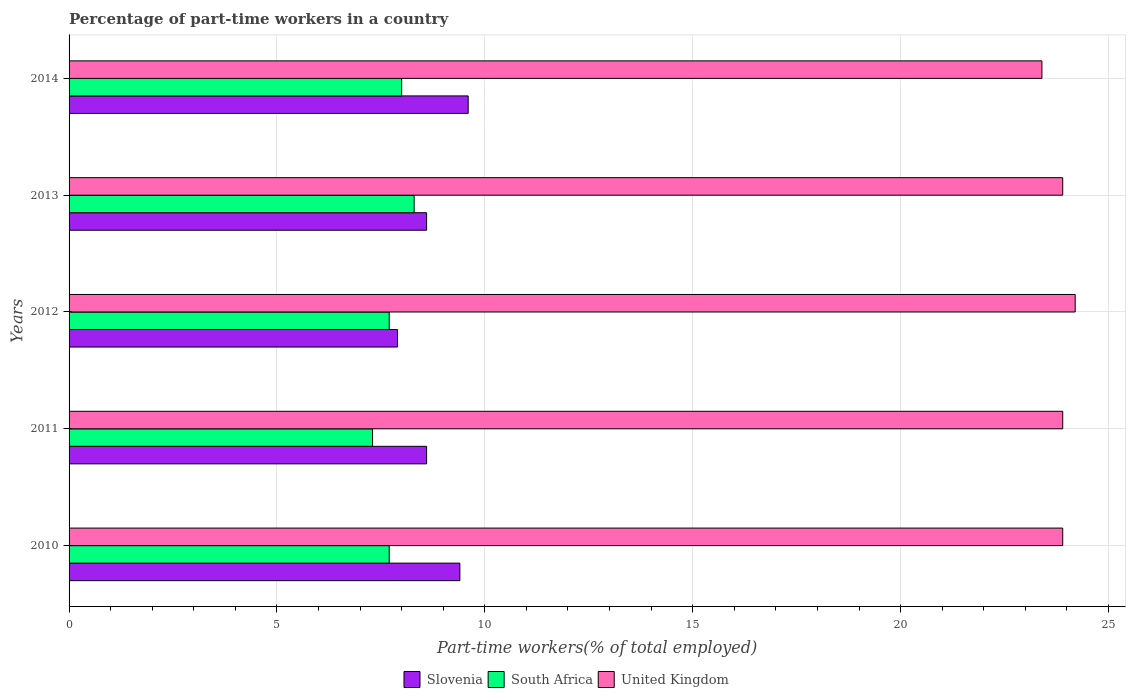How many different coloured bars are there?
Make the answer very short. 3. Are the number of bars per tick equal to the number of legend labels?
Ensure brevity in your answer.  Yes. Are the number of bars on each tick of the Y-axis equal?
Provide a succinct answer. Yes. What is the label of the 3rd group of bars from the top?
Make the answer very short. 2012. In how many cases, is the number of bars for a given year not equal to the number of legend labels?
Your response must be concise. 0. What is the percentage of part-time workers in South Africa in 2012?
Your answer should be very brief. 7.7. Across all years, what is the maximum percentage of part-time workers in Slovenia?
Keep it short and to the point. 9.6. Across all years, what is the minimum percentage of part-time workers in United Kingdom?
Make the answer very short. 23.4. In which year was the percentage of part-time workers in Slovenia maximum?
Make the answer very short. 2014. In which year was the percentage of part-time workers in Slovenia minimum?
Keep it short and to the point. 2012. What is the total percentage of part-time workers in United Kingdom in the graph?
Offer a terse response. 119.3. What is the difference between the percentage of part-time workers in South Africa in 2012 and that in 2013?
Offer a terse response. -0.6. What is the difference between the percentage of part-time workers in United Kingdom in 2010 and the percentage of part-time workers in South Africa in 2014?
Ensure brevity in your answer.  15.9. What is the average percentage of part-time workers in South Africa per year?
Keep it short and to the point. 7.8. In the year 2010, what is the difference between the percentage of part-time workers in United Kingdom and percentage of part-time workers in South Africa?
Ensure brevity in your answer.  16.2. What is the ratio of the percentage of part-time workers in Slovenia in 2011 to that in 2014?
Your answer should be very brief. 0.9. Is the difference between the percentage of part-time workers in United Kingdom in 2012 and 2013 greater than the difference between the percentage of part-time workers in South Africa in 2012 and 2013?
Ensure brevity in your answer.  Yes. What is the difference between the highest and the second highest percentage of part-time workers in Slovenia?
Ensure brevity in your answer.  0.2. What is the difference between the highest and the lowest percentage of part-time workers in Slovenia?
Make the answer very short. 1.7. In how many years, is the percentage of part-time workers in Slovenia greater than the average percentage of part-time workers in Slovenia taken over all years?
Your answer should be compact. 2. What does the 1st bar from the bottom in 2011 represents?
Make the answer very short. Slovenia. Is it the case that in every year, the sum of the percentage of part-time workers in Slovenia and percentage of part-time workers in South Africa is greater than the percentage of part-time workers in United Kingdom?
Provide a short and direct response. No. Are all the bars in the graph horizontal?
Provide a succinct answer. Yes. What is the difference between two consecutive major ticks on the X-axis?
Make the answer very short. 5. Does the graph contain any zero values?
Your answer should be compact. No. Does the graph contain grids?
Your answer should be compact. Yes. Where does the legend appear in the graph?
Your answer should be very brief. Bottom center. How many legend labels are there?
Keep it short and to the point. 3. What is the title of the graph?
Give a very brief answer. Percentage of part-time workers in a country. What is the label or title of the X-axis?
Provide a short and direct response. Part-time workers(% of total employed). What is the Part-time workers(% of total employed) of Slovenia in 2010?
Your answer should be very brief. 9.4. What is the Part-time workers(% of total employed) in South Africa in 2010?
Offer a very short reply. 7.7. What is the Part-time workers(% of total employed) of United Kingdom in 2010?
Keep it short and to the point. 23.9. What is the Part-time workers(% of total employed) of Slovenia in 2011?
Your answer should be very brief. 8.6. What is the Part-time workers(% of total employed) of South Africa in 2011?
Offer a very short reply. 7.3. What is the Part-time workers(% of total employed) in United Kingdom in 2011?
Keep it short and to the point. 23.9. What is the Part-time workers(% of total employed) of Slovenia in 2012?
Your response must be concise. 7.9. What is the Part-time workers(% of total employed) in South Africa in 2012?
Keep it short and to the point. 7.7. What is the Part-time workers(% of total employed) in United Kingdom in 2012?
Offer a very short reply. 24.2. What is the Part-time workers(% of total employed) of Slovenia in 2013?
Offer a terse response. 8.6. What is the Part-time workers(% of total employed) of South Africa in 2013?
Give a very brief answer. 8.3. What is the Part-time workers(% of total employed) of United Kingdom in 2013?
Give a very brief answer. 23.9. What is the Part-time workers(% of total employed) in Slovenia in 2014?
Your response must be concise. 9.6. What is the Part-time workers(% of total employed) of South Africa in 2014?
Ensure brevity in your answer.  8. What is the Part-time workers(% of total employed) of United Kingdom in 2014?
Make the answer very short. 23.4. Across all years, what is the maximum Part-time workers(% of total employed) in Slovenia?
Give a very brief answer. 9.6. Across all years, what is the maximum Part-time workers(% of total employed) of South Africa?
Ensure brevity in your answer.  8.3. Across all years, what is the maximum Part-time workers(% of total employed) in United Kingdom?
Your answer should be very brief. 24.2. Across all years, what is the minimum Part-time workers(% of total employed) in Slovenia?
Provide a short and direct response. 7.9. Across all years, what is the minimum Part-time workers(% of total employed) in South Africa?
Offer a terse response. 7.3. Across all years, what is the minimum Part-time workers(% of total employed) of United Kingdom?
Your response must be concise. 23.4. What is the total Part-time workers(% of total employed) in Slovenia in the graph?
Your answer should be very brief. 44.1. What is the total Part-time workers(% of total employed) in United Kingdom in the graph?
Give a very brief answer. 119.3. What is the difference between the Part-time workers(% of total employed) in Slovenia in 2010 and that in 2011?
Your answer should be compact. 0.8. What is the difference between the Part-time workers(% of total employed) of South Africa in 2010 and that in 2011?
Keep it short and to the point. 0.4. What is the difference between the Part-time workers(% of total employed) of Slovenia in 2010 and that in 2012?
Your response must be concise. 1.5. What is the difference between the Part-time workers(% of total employed) in South Africa in 2010 and that in 2012?
Provide a short and direct response. 0. What is the difference between the Part-time workers(% of total employed) in United Kingdom in 2010 and that in 2012?
Provide a short and direct response. -0.3. What is the difference between the Part-time workers(% of total employed) of South Africa in 2010 and that in 2013?
Keep it short and to the point. -0.6. What is the difference between the Part-time workers(% of total employed) in United Kingdom in 2010 and that in 2013?
Provide a short and direct response. 0. What is the difference between the Part-time workers(% of total employed) in Slovenia in 2010 and that in 2014?
Keep it short and to the point. -0.2. What is the difference between the Part-time workers(% of total employed) in South Africa in 2010 and that in 2014?
Give a very brief answer. -0.3. What is the difference between the Part-time workers(% of total employed) of United Kingdom in 2011 and that in 2012?
Provide a short and direct response. -0.3. What is the difference between the Part-time workers(% of total employed) of South Africa in 2012 and that in 2013?
Your response must be concise. -0.6. What is the difference between the Part-time workers(% of total employed) in Slovenia in 2012 and that in 2014?
Your response must be concise. -1.7. What is the difference between the Part-time workers(% of total employed) in United Kingdom in 2012 and that in 2014?
Ensure brevity in your answer.  0.8. What is the difference between the Part-time workers(% of total employed) in Slovenia in 2013 and that in 2014?
Provide a short and direct response. -1. What is the difference between the Part-time workers(% of total employed) in United Kingdom in 2013 and that in 2014?
Keep it short and to the point. 0.5. What is the difference between the Part-time workers(% of total employed) of Slovenia in 2010 and the Part-time workers(% of total employed) of South Africa in 2011?
Your response must be concise. 2.1. What is the difference between the Part-time workers(% of total employed) in Slovenia in 2010 and the Part-time workers(% of total employed) in United Kingdom in 2011?
Offer a very short reply. -14.5. What is the difference between the Part-time workers(% of total employed) of South Africa in 2010 and the Part-time workers(% of total employed) of United Kingdom in 2011?
Make the answer very short. -16.2. What is the difference between the Part-time workers(% of total employed) in Slovenia in 2010 and the Part-time workers(% of total employed) in United Kingdom in 2012?
Offer a very short reply. -14.8. What is the difference between the Part-time workers(% of total employed) of South Africa in 2010 and the Part-time workers(% of total employed) of United Kingdom in 2012?
Make the answer very short. -16.5. What is the difference between the Part-time workers(% of total employed) of Slovenia in 2010 and the Part-time workers(% of total employed) of United Kingdom in 2013?
Your response must be concise. -14.5. What is the difference between the Part-time workers(% of total employed) of South Africa in 2010 and the Part-time workers(% of total employed) of United Kingdom in 2013?
Your answer should be compact. -16.2. What is the difference between the Part-time workers(% of total employed) of Slovenia in 2010 and the Part-time workers(% of total employed) of South Africa in 2014?
Your answer should be compact. 1.4. What is the difference between the Part-time workers(% of total employed) in South Africa in 2010 and the Part-time workers(% of total employed) in United Kingdom in 2014?
Your response must be concise. -15.7. What is the difference between the Part-time workers(% of total employed) in Slovenia in 2011 and the Part-time workers(% of total employed) in South Africa in 2012?
Your response must be concise. 0.9. What is the difference between the Part-time workers(% of total employed) in Slovenia in 2011 and the Part-time workers(% of total employed) in United Kingdom in 2012?
Your answer should be compact. -15.6. What is the difference between the Part-time workers(% of total employed) of South Africa in 2011 and the Part-time workers(% of total employed) of United Kingdom in 2012?
Keep it short and to the point. -16.9. What is the difference between the Part-time workers(% of total employed) in Slovenia in 2011 and the Part-time workers(% of total employed) in South Africa in 2013?
Provide a short and direct response. 0.3. What is the difference between the Part-time workers(% of total employed) in Slovenia in 2011 and the Part-time workers(% of total employed) in United Kingdom in 2013?
Your response must be concise. -15.3. What is the difference between the Part-time workers(% of total employed) in South Africa in 2011 and the Part-time workers(% of total employed) in United Kingdom in 2013?
Your response must be concise. -16.6. What is the difference between the Part-time workers(% of total employed) of Slovenia in 2011 and the Part-time workers(% of total employed) of South Africa in 2014?
Your response must be concise. 0.6. What is the difference between the Part-time workers(% of total employed) of Slovenia in 2011 and the Part-time workers(% of total employed) of United Kingdom in 2014?
Make the answer very short. -14.8. What is the difference between the Part-time workers(% of total employed) in South Africa in 2011 and the Part-time workers(% of total employed) in United Kingdom in 2014?
Your answer should be compact. -16.1. What is the difference between the Part-time workers(% of total employed) in Slovenia in 2012 and the Part-time workers(% of total employed) in South Africa in 2013?
Provide a succinct answer. -0.4. What is the difference between the Part-time workers(% of total employed) in Slovenia in 2012 and the Part-time workers(% of total employed) in United Kingdom in 2013?
Provide a short and direct response. -16. What is the difference between the Part-time workers(% of total employed) of South Africa in 2012 and the Part-time workers(% of total employed) of United Kingdom in 2013?
Your answer should be very brief. -16.2. What is the difference between the Part-time workers(% of total employed) in Slovenia in 2012 and the Part-time workers(% of total employed) in United Kingdom in 2014?
Give a very brief answer. -15.5. What is the difference between the Part-time workers(% of total employed) in South Africa in 2012 and the Part-time workers(% of total employed) in United Kingdom in 2014?
Your response must be concise. -15.7. What is the difference between the Part-time workers(% of total employed) of Slovenia in 2013 and the Part-time workers(% of total employed) of United Kingdom in 2014?
Your answer should be compact. -14.8. What is the difference between the Part-time workers(% of total employed) of South Africa in 2013 and the Part-time workers(% of total employed) of United Kingdom in 2014?
Your answer should be compact. -15.1. What is the average Part-time workers(% of total employed) of Slovenia per year?
Offer a terse response. 8.82. What is the average Part-time workers(% of total employed) in South Africa per year?
Provide a succinct answer. 7.8. What is the average Part-time workers(% of total employed) in United Kingdom per year?
Keep it short and to the point. 23.86. In the year 2010, what is the difference between the Part-time workers(% of total employed) in South Africa and Part-time workers(% of total employed) in United Kingdom?
Offer a terse response. -16.2. In the year 2011, what is the difference between the Part-time workers(% of total employed) of Slovenia and Part-time workers(% of total employed) of South Africa?
Keep it short and to the point. 1.3. In the year 2011, what is the difference between the Part-time workers(% of total employed) of Slovenia and Part-time workers(% of total employed) of United Kingdom?
Offer a very short reply. -15.3. In the year 2011, what is the difference between the Part-time workers(% of total employed) in South Africa and Part-time workers(% of total employed) in United Kingdom?
Your answer should be compact. -16.6. In the year 2012, what is the difference between the Part-time workers(% of total employed) of Slovenia and Part-time workers(% of total employed) of South Africa?
Your response must be concise. 0.2. In the year 2012, what is the difference between the Part-time workers(% of total employed) of Slovenia and Part-time workers(% of total employed) of United Kingdom?
Your answer should be compact. -16.3. In the year 2012, what is the difference between the Part-time workers(% of total employed) of South Africa and Part-time workers(% of total employed) of United Kingdom?
Offer a very short reply. -16.5. In the year 2013, what is the difference between the Part-time workers(% of total employed) in Slovenia and Part-time workers(% of total employed) in United Kingdom?
Ensure brevity in your answer.  -15.3. In the year 2013, what is the difference between the Part-time workers(% of total employed) of South Africa and Part-time workers(% of total employed) of United Kingdom?
Offer a very short reply. -15.6. In the year 2014, what is the difference between the Part-time workers(% of total employed) in Slovenia and Part-time workers(% of total employed) in United Kingdom?
Ensure brevity in your answer.  -13.8. In the year 2014, what is the difference between the Part-time workers(% of total employed) in South Africa and Part-time workers(% of total employed) in United Kingdom?
Your answer should be compact. -15.4. What is the ratio of the Part-time workers(% of total employed) of Slovenia in 2010 to that in 2011?
Provide a short and direct response. 1.09. What is the ratio of the Part-time workers(% of total employed) in South Africa in 2010 to that in 2011?
Provide a short and direct response. 1.05. What is the ratio of the Part-time workers(% of total employed) of United Kingdom in 2010 to that in 2011?
Provide a succinct answer. 1. What is the ratio of the Part-time workers(% of total employed) in Slovenia in 2010 to that in 2012?
Offer a very short reply. 1.19. What is the ratio of the Part-time workers(% of total employed) in United Kingdom in 2010 to that in 2012?
Your answer should be compact. 0.99. What is the ratio of the Part-time workers(% of total employed) in Slovenia in 2010 to that in 2013?
Offer a terse response. 1.09. What is the ratio of the Part-time workers(% of total employed) in South Africa in 2010 to that in 2013?
Your response must be concise. 0.93. What is the ratio of the Part-time workers(% of total employed) in Slovenia in 2010 to that in 2014?
Offer a terse response. 0.98. What is the ratio of the Part-time workers(% of total employed) of South Africa in 2010 to that in 2014?
Ensure brevity in your answer.  0.96. What is the ratio of the Part-time workers(% of total employed) of United Kingdom in 2010 to that in 2014?
Offer a very short reply. 1.02. What is the ratio of the Part-time workers(% of total employed) of Slovenia in 2011 to that in 2012?
Make the answer very short. 1.09. What is the ratio of the Part-time workers(% of total employed) in South Africa in 2011 to that in 2012?
Offer a terse response. 0.95. What is the ratio of the Part-time workers(% of total employed) of United Kingdom in 2011 to that in 2012?
Your answer should be compact. 0.99. What is the ratio of the Part-time workers(% of total employed) of Slovenia in 2011 to that in 2013?
Ensure brevity in your answer.  1. What is the ratio of the Part-time workers(% of total employed) of South Africa in 2011 to that in 2013?
Give a very brief answer. 0.88. What is the ratio of the Part-time workers(% of total employed) of Slovenia in 2011 to that in 2014?
Ensure brevity in your answer.  0.9. What is the ratio of the Part-time workers(% of total employed) in South Africa in 2011 to that in 2014?
Your response must be concise. 0.91. What is the ratio of the Part-time workers(% of total employed) in United Kingdom in 2011 to that in 2014?
Provide a succinct answer. 1.02. What is the ratio of the Part-time workers(% of total employed) in Slovenia in 2012 to that in 2013?
Keep it short and to the point. 0.92. What is the ratio of the Part-time workers(% of total employed) in South Africa in 2012 to that in 2013?
Your answer should be compact. 0.93. What is the ratio of the Part-time workers(% of total employed) of United Kingdom in 2012 to that in 2013?
Provide a succinct answer. 1.01. What is the ratio of the Part-time workers(% of total employed) in Slovenia in 2012 to that in 2014?
Provide a short and direct response. 0.82. What is the ratio of the Part-time workers(% of total employed) of South Africa in 2012 to that in 2014?
Offer a terse response. 0.96. What is the ratio of the Part-time workers(% of total employed) in United Kingdom in 2012 to that in 2014?
Offer a very short reply. 1.03. What is the ratio of the Part-time workers(% of total employed) of Slovenia in 2013 to that in 2014?
Your answer should be compact. 0.9. What is the ratio of the Part-time workers(% of total employed) of South Africa in 2013 to that in 2014?
Provide a succinct answer. 1.04. What is the ratio of the Part-time workers(% of total employed) of United Kingdom in 2013 to that in 2014?
Your answer should be very brief. 1.02. What is the difference between the highest and the lowest Part-time workers(% of total employed) in United Kingdom?
Offer a very short reply. 0.8. 